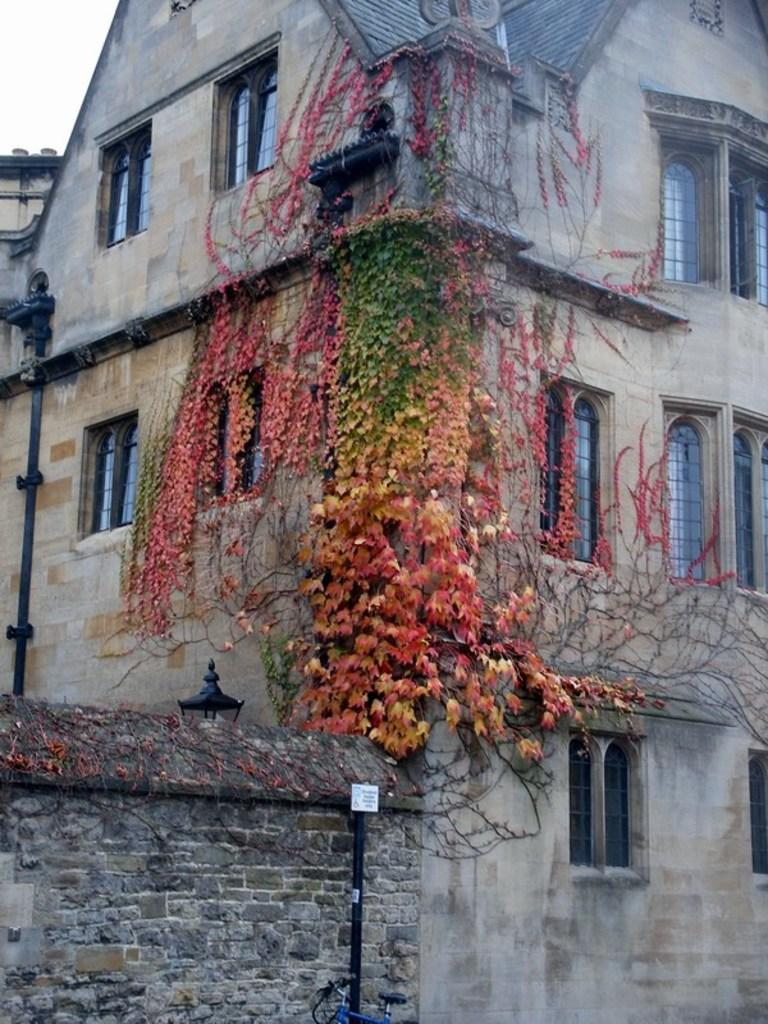What structure is visible in the image? There is a building in the image. What is located in front of the building? There are branches of plants in front of the building. How many children are playing near the building in the image? There is no mention of children in the image; it only features a building and branches of plants. What type of bird can be seen perched on the lamp near the building? There is no lamp or bird present in the image; it only features a building and branches of plants. 